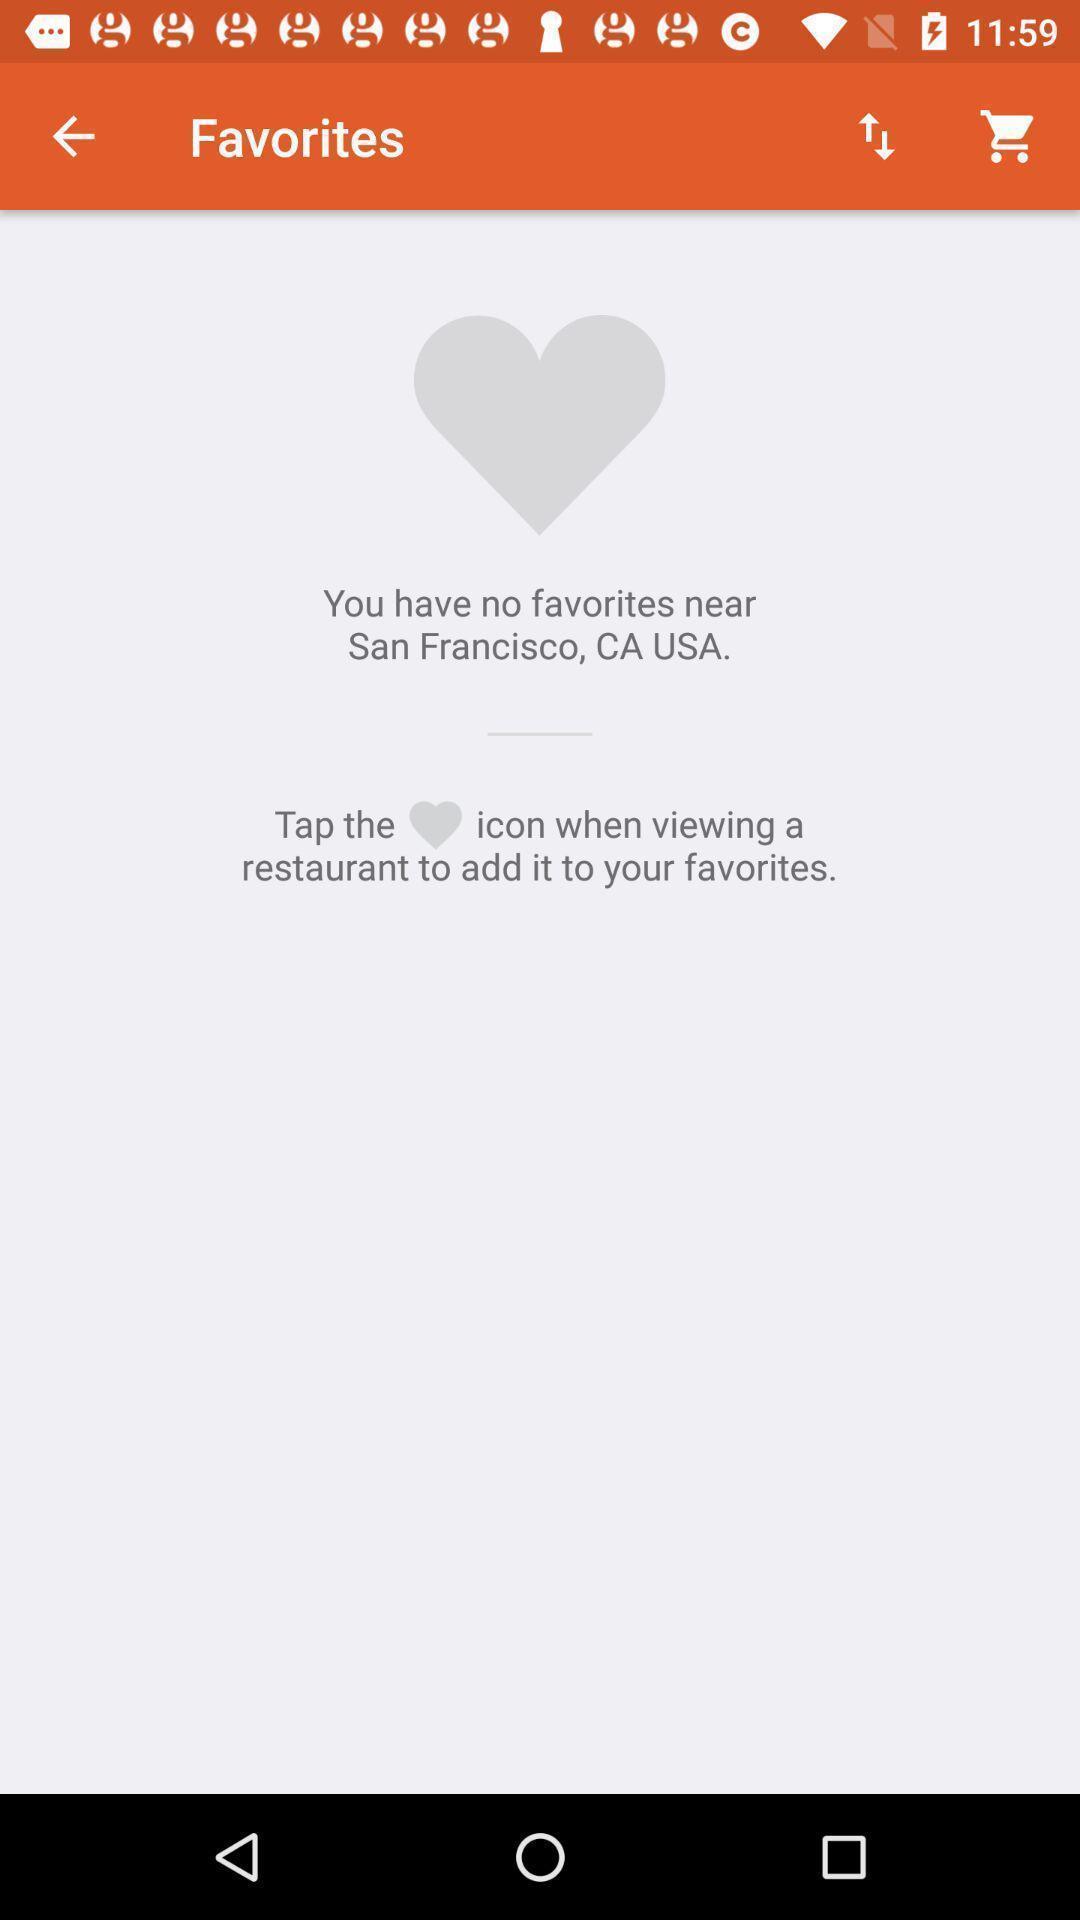Give me a summary of this screen capture. Page displaying with no list of favorites near the location. 